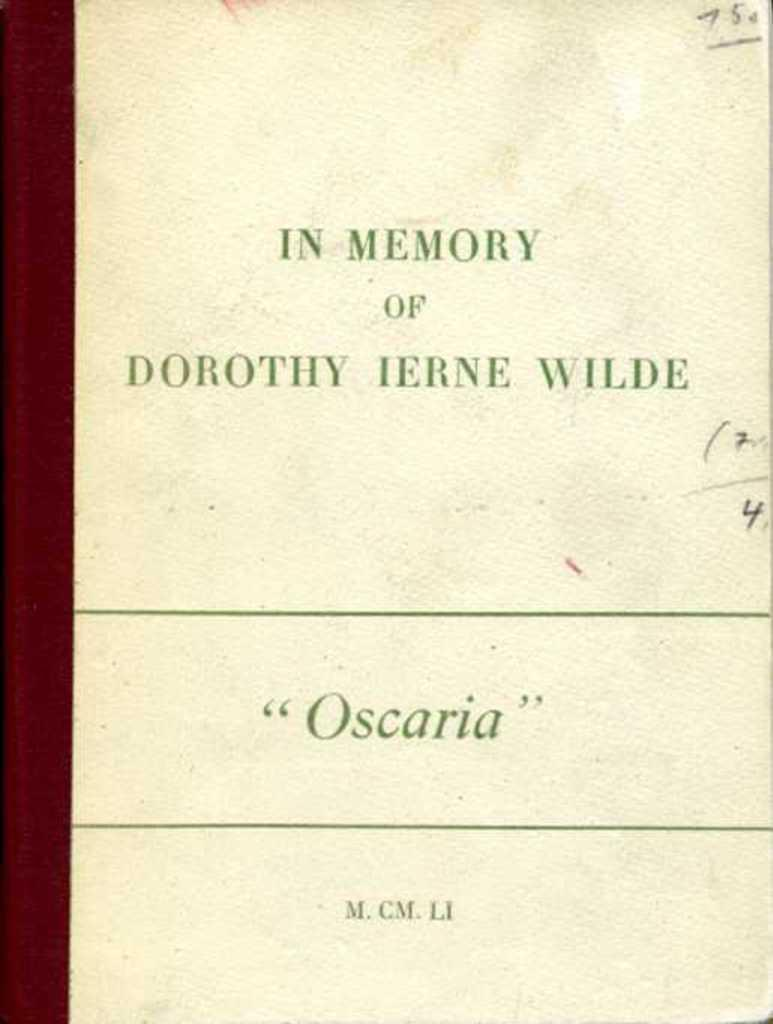What can be seen in the image? There is an object in the image. What is unique about the object? The object has something written on it. What type of toy is the person playing with in the image? There is no person or toy present in the image; it only features an object with writing on it. 